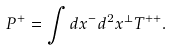<formula> <loc_0><loc_0><loc_500><loc_500>P ^ { + } = \int d x ^ { - } d ^ { 2 } x ^ { \perp } T ^ { + + } .</formula> 